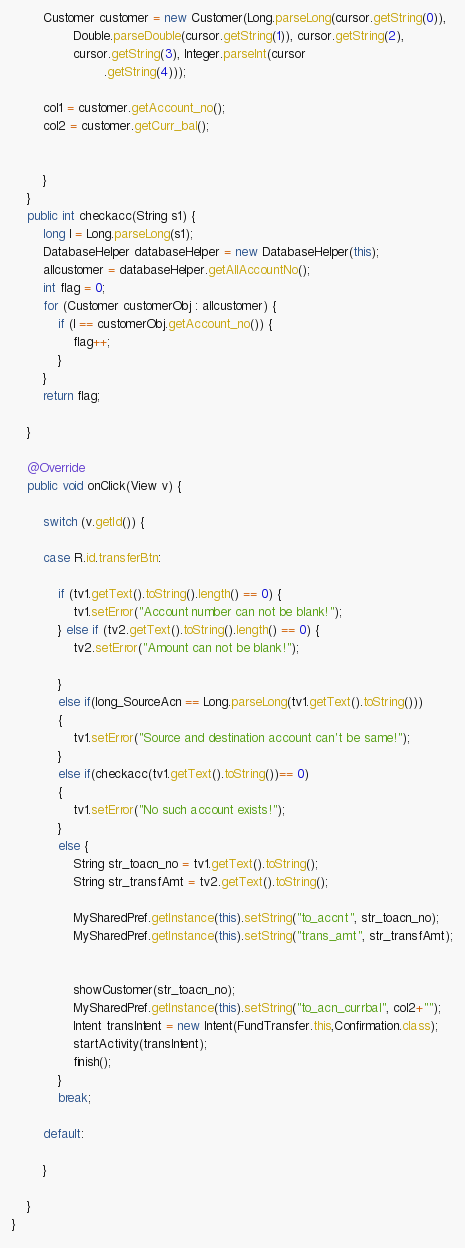<code> <loc_0><loc_0><loc_500><loc_500><_Java_>		Customer customer = new Customer(Long.parseLong(cursor.getString(0)),
				Double.parseDouble(cursor.getString(1)), cursor.getString(2),
				cursor.getString(3), Integer.parseInt(cursor
						.getString(4)));
      
		col1 = customer.getAccount_no();
		col2 = customer.getCurr_bal();
		
		
		}
	}
	public int checkacc(String s1) {
        long l = Long.parseLong(s1);
		DatabaseHelper databaseHelper = new DatabaseHelper(this);
		allcustomer = databaseHelper.getAllAccountNo();
        int flag = 0;
		for (Customer customerObj : allcustomer) {
			if (l == customerObj.getAccount_no()) {
				flag++;
			} 
		}
		return flag;

	}

	@Override
	public void onClick(View v) {

		switch (v.getId()) {

		case R.id.transferBtn:

			if (tv1.getText().toString().length() == 0) {
				tv1.setError("Account number can not be blank!");
			} else if (tv2.getText().toString().length() == 0) {
				tv2.setError("Amount can not be blank!");
				
			}
			else if(long_SourceAcn == Long.parseLong(tv1.getText().toString()))
			{
				tv1.setError("Source and destination account can't be same!");
			}
			else if(checkacc(tv1.getText().toString())== 0)
			{
				tv1.setError("No such account exists!");
			}
			else {
				String str_toacn_no = tv1.getText().toString();
				String str_transfAmt = tv2.getText().toString();
				
				MySharedPref.getInstance(this).setString("to_accnt", str_toacn_no);
				MySharedPref.getInstance(this).setString("trans_amt", str_transfAmt);
				
				
				showCustomer(str_toacn_no);
				MySharedPref.getInstance(this).setString("to_acn_currbal", col2+"");
                Intent transIntent = new Intent(FundTransfer.this,Confirmation.class);
				startActivity(transIntent);
				finish();
			}
			break;

		default:

		}

	}
}
</code> 